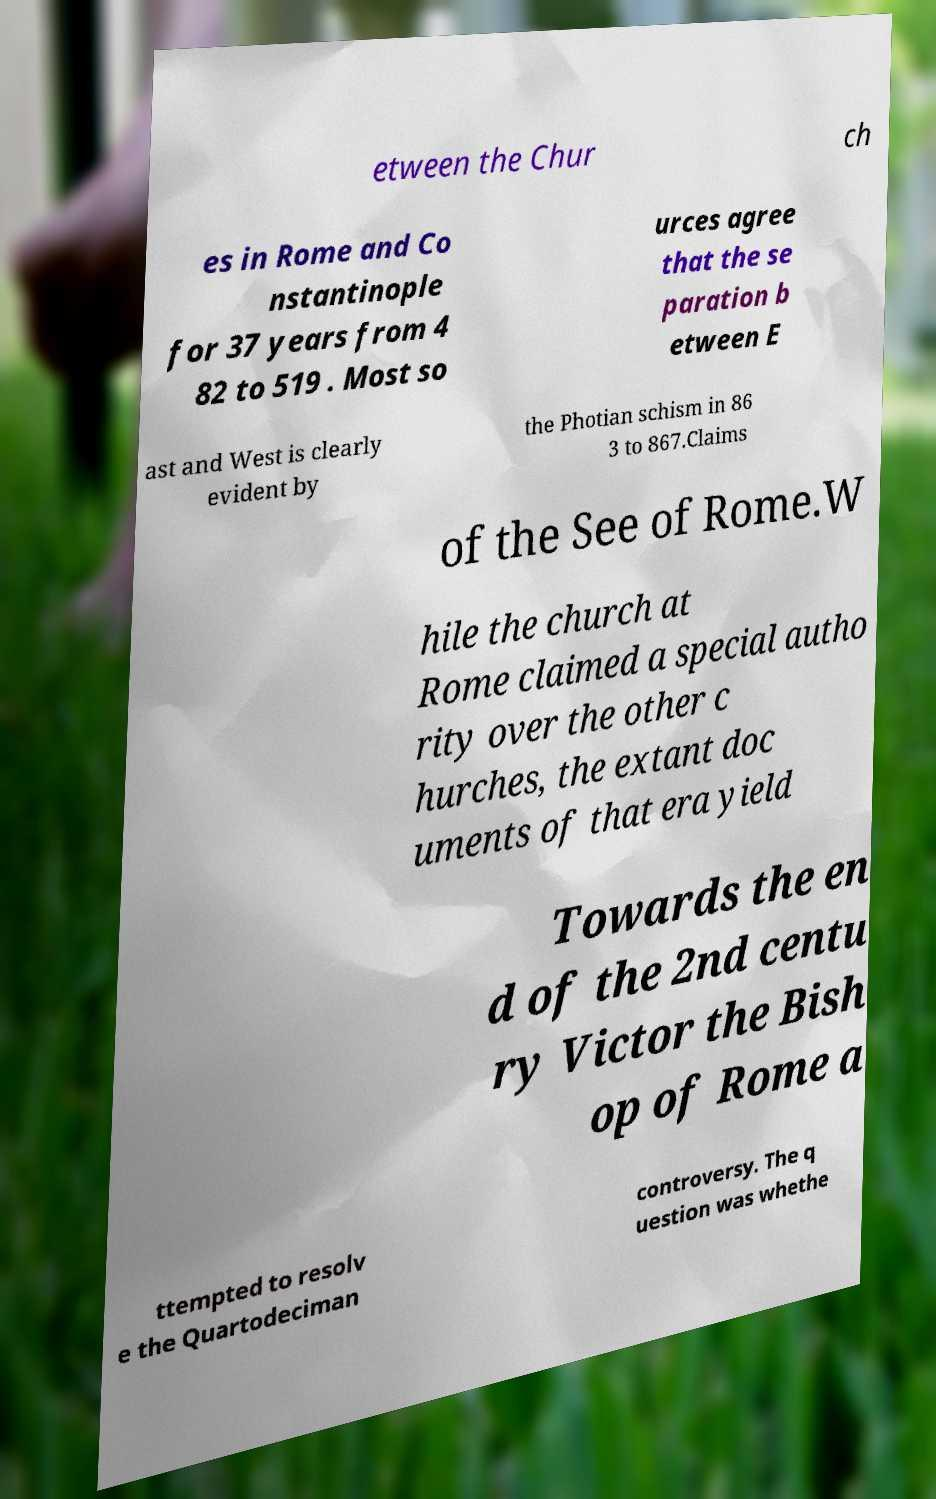For documentation purposes, I need the text within this image transcribed. Could you provide that? etween the Chur ch es in Rome and Co nstantinople for 37 years from 4 82 to 519 . Most so urces agree that the se paration b etween E ast and West is clearly evident by the Photian schism in 86 3 to 867.Claims of the See of Rome.W hile the church at Rome claimed a special autho rity over the other c hurches, the extant doc uments of that era yield Towards the en d of the 2nd centu ry Victor the Bish op of Rome a ttempted to resolv e the Quartodeciman controversy. The q uestion was whethe 